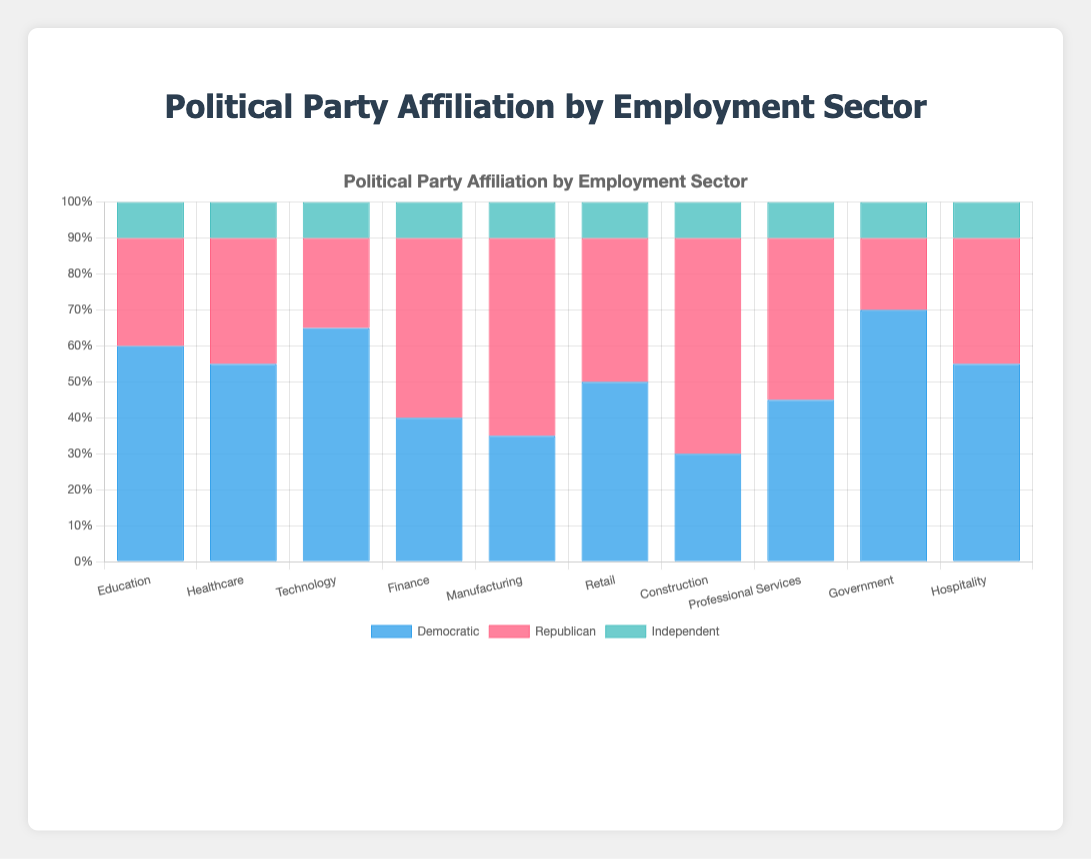Which employment sector has the highest percentage of Democratic affiliation? By looking at the height of the blue segments in the bar chart for each employment sector, the Government sector has the highest percentage of Democratic affiliation with 70%.
Answer: Government Compare the Republican affiliation in the Technology and Manufacturing sectors. Which sector has a higher percentage? The Republican affiliation is represented by the red segments in the bar chart. The Technology sector has a Republican percentage of 25%, while the Manufacturing sector has a Republican percentage of 55%. Hence, Manufacturing has a higher Republican percentage.
Answer: Manufacturing What is the combined percentage of Independent affiliation across all employment sectors? We add the Independent percentages from all sectors: 10 + 10 + 10 + 10 + 10 + 10 + 10 + 10 + 10 + 10 = 100%.
Answer: 100% How does the Democratic affiliation in Healthcare compare to that in Hospitality? By examining the height of the blue segments, both Healthcare and Hospitality sectors have the same Democratic percentage, which is 55%.
Answer: 55% and 55% Which sector has the most balanced distribution of political affiliations among Democratic, Republican, and Independent? To find the most balanced distribution, we look for the sector where the segments have the least variance in their heights. The Professional Services sector has an equal distribution of 45% Democratic, 45% Republican, and 10% Independent.
Answer: Professional Services Determine the employment sector with the largest disparity between Democratic and Republican affiliations. We calculate the difference between Democratic and Republican percentages for each sector:  
Education: 60 - 30 = 30  
Healthcare: 55 - 35 = 20  
Technology: 65 - 25 = 40  
Finance: 40 - 50 = -10  
Manufacturing: 35 - 55 = -20  
Retail: 50 - 40 = 10  
Construction: 30 - 60 = -30  
Professional Services: 45 - 45 = 0  
Government: 70 - 20 = 50  
Hospitality: 55 - 35 = 20  
The Government sector has the largest disparity with a 50% difference.
Answer: Government Which sectors have a Democratic percentage greater than 60%? The sectors where the height of the blue segments exceeds 60% are Technology (65%) and Government (70%).
Answer: Technology and Government What's the average Republican affiliation in the Finance, Retail, and Construction sectors? We calculate the average of Republican percentages in the Finance (50%), Retail (40%), and Construction (60%) sectors:  
(50 + 40 + 60) / 3 = 50%.
Answer: 50% Which sector has the lowest percentage of Democratic affiliation? By observing the height of the blue segments, the Construction sector has the lowest Democratic percentage, which is 30%.
Answer: Construction What is the difference between the maximum and minimum percentage of Independent affiliation across all sectors? The Independent percentage is consistently 10% across all sectors. Therefore, the difference is 0.
Answer: 0 